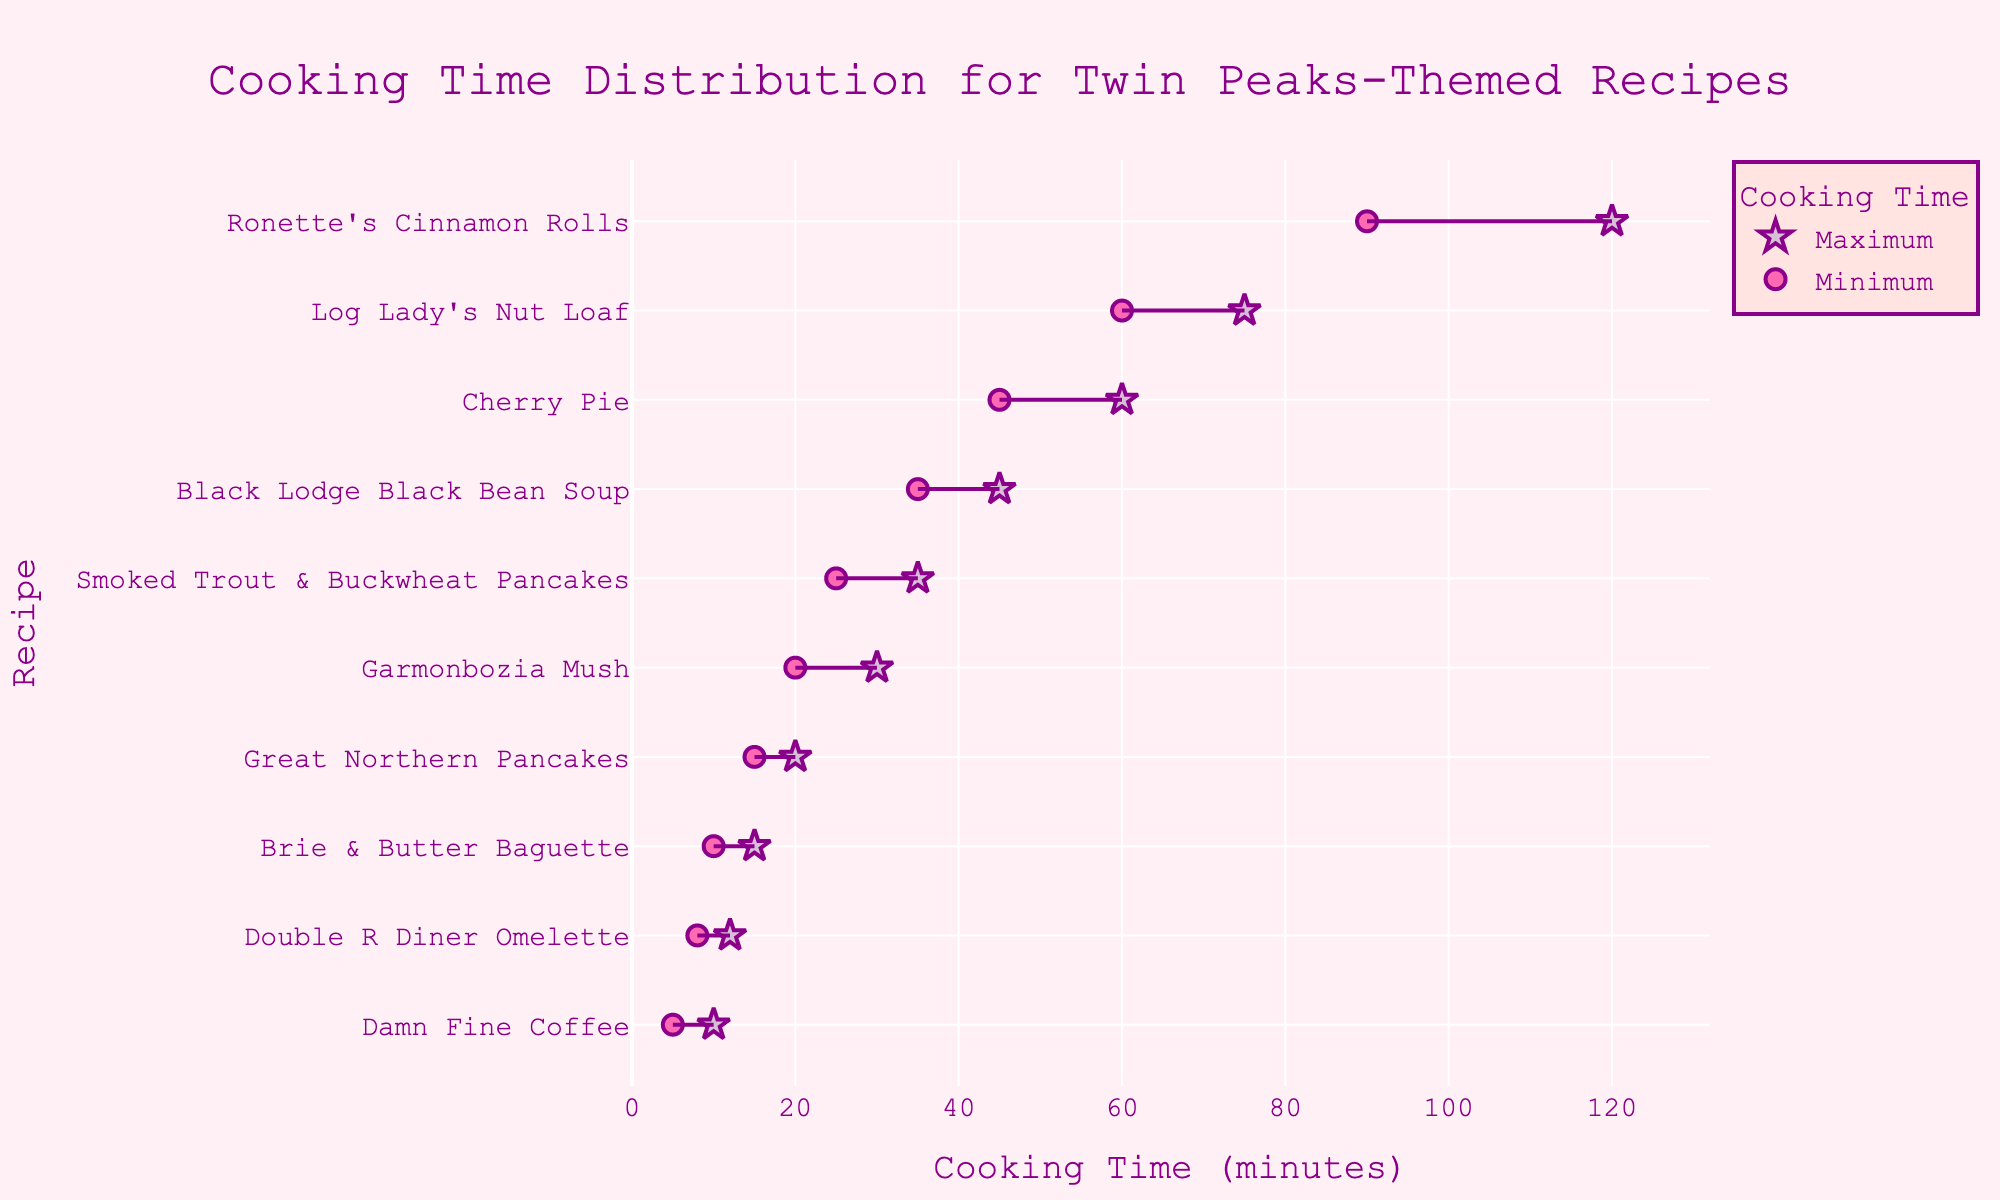What is the title of the plot? The title is visible at the top of the plot and it states "Cooking Time Distribution for Twin Peaks-Themed Recipes".
Answer: Cooking Time Distribution for Twin Peaks-Themed Recipes Which recipe has the shortest minimum cooking time? The plot shows two markers for each recipe, one for minimum and one for maximum cooking time. The shortest minimum cooking time is for "Damn Fine Coffee".
Answer: Damn Fine Coffee Which recipe requires the longest possible cooking time? By examining the maximum points, we can see that "Ronette's Cinnamon Rolls" has the highest value, reaching up to 120 minutes.
Answer: Ronette's Cinnamon Rolls What is the range of cooking times for Black Lodge Black Bean Soup? The start and end of the line connecting the two markers for "Black Lodge Black Bean Soup" indicate the range. It ranges from 35 to 45 minutes.
Answer: 35 to 45 minutes What is the average maximum cooking time across all recipes? Sum the maximum cooking times for all recipes (60 + 10 + 15 + 30 + 75 + 35 + 12 + 45 + 20 + 120) to get 422. There are 10 recipes, so the average is 422/10.
Answer: 42.2 minutes Which recipe has the smallest range of cooking times? The range is the difference between maximum and minimum cooking times. "Double R Diner Omelette" has a range of (12 - 8), which is 4 minutes, the smallest in the plot.
Answer: Double R Diner Omelette How much longer is the cooking time range for Ronette's Cinnamon Rolls compared to Cherry Pie? The range for "Ronette's Cinnamon Rolls" is (120 - 90) = 30 minutes, and for "Cherry Pie" it is (60 - 45) = 15 minutes. The difference is 30 - 15 = 15 minutes.
Answer: 15 minutes What is the total cooking time range for all recipes combined? The minimum combined range is the start of the earliest minimum time (5 minutes for Damn Fine Coffee) to the end of the latest maximum time (120 minutes for Ronette's Cinnamon Rolls), which is 120 - 5.
Answer: 115 minutes Which recipe has a maximum cooking time greater than the average maximum cooking time across all recipes but less than 50 minutes? The average maximum cooking time is approximately 42.2 minutes. Examining the maximum points, "Black Lodge Black Bean Soup" at 45 minutes fits this criterion.
Answer: Black Lodge Black Bean Soup 